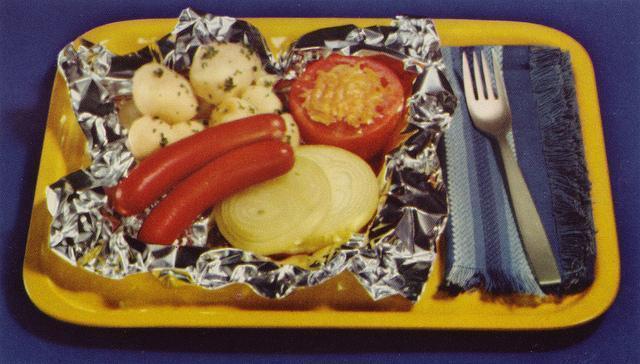How many sausages are on the tray?
Give a very brief answer. 2. How many hot dogs are there?
Give a very brief answer. 2. 